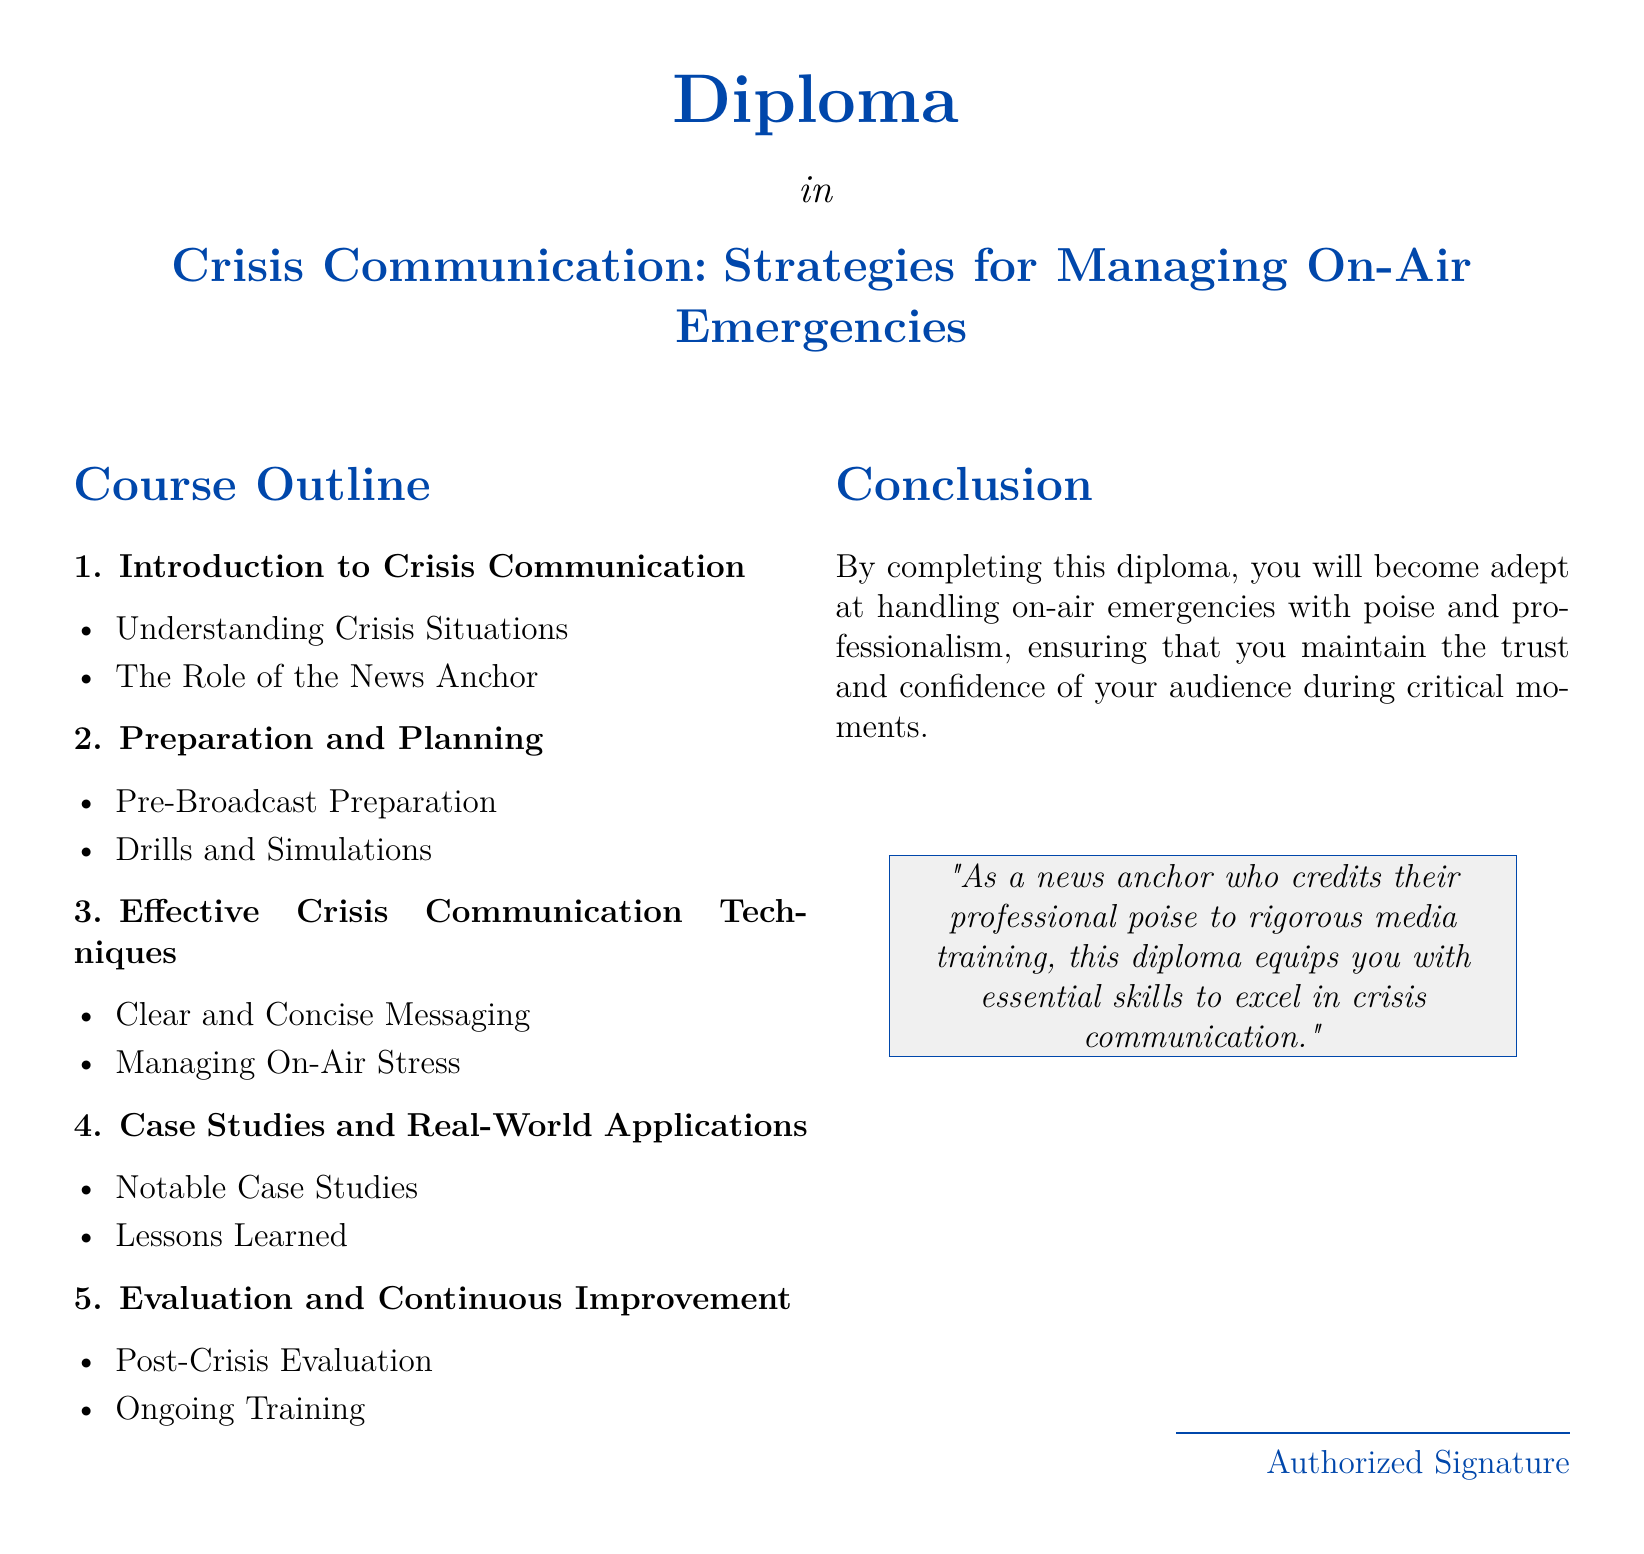What is the title of the diploma? The title of the diploma is stated at the top of the document, which is "Crisis Communication: Strategies for Managing On-Air Emergencies."
Answer: Crisis Communication: Strategies for Managing On-Air Emergencies How many main sections are in the course outline? The document outlines five main sections under the course outline.
Answer: 5 What is the first topic of the first section? The first topic in the first section, "Introduction to Crisis Communication," is "Understanding Crisis Situations."
Answer: Understanding Crisis Situations What is one technique emphasized for effective crisis communication? The document lists "Clear and Concise Messaging" as one of the effective crisis communication techniques.
Answer: Clear and Concise Messaging What should be evaluated post-crisis according to the course outline? The document states that "Post-Crisis Evaluation" is an important aspect to look at after a crisis.
Answer: Post-Crisis Evaluation What color is used for the diploma title? The color used for the diploma title is specified in the document as news blue.
Answer: news blue How does the conclusion describe the benefit of completing the diploma? The conclusion emphasizes that completing the diploma equips the individual with essential skills.
Answer: essential skills What is highlighted in the diploma's conclusion pertaining to the news anchor's role? The conclusion indicates that the diploma helps maintain the trust and confidence of the audience.
Answer: trust and confidence 